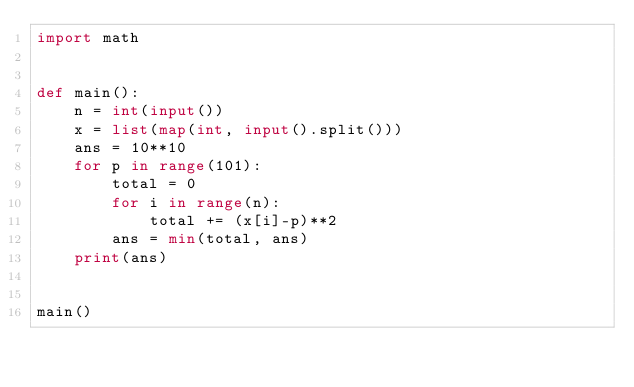<code> <loc_0><loc_0><loc_500><loc_500><_Python_>import math


def main():
    n = int(input())
    x = list(map(int, input().split()))
    ans = 10**10
    for p in range(101):
        total = 0
        for i in range(n):
            total += (x[i]-p)**2
        ans = min(total, ans)
    print(ans)


main()
</code> 